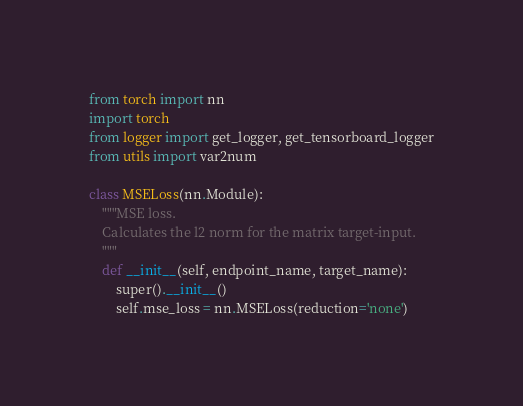Convert code to text. <code><loc_0><loc_0><loc_500><loc_500><_Python_>from torch import nn
import torch
from logger import get_logger, get_tensorboard_logger
from utils import var2num

class MSELoss(nn.Module):
    """MSE loss.
    Calculates the l2 norm for the matrix target-input.
    """
    def __init__(self, endpoint_name, target_name):
        super().__init__()
        self.mse_loss = nn.MSELoss(reduction='none')</code> 